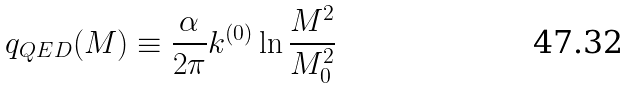<formula> <loc_0><loc_0><loc_500><loc_500>q _ { Q E D } ( M ) \equiv \frac { \alpha } { 2 \pi } k ^ { ( 0 ) } \ln \frac { M ^ { 2 } } { M _ { 0 } ^ { 2 } }</formula> 